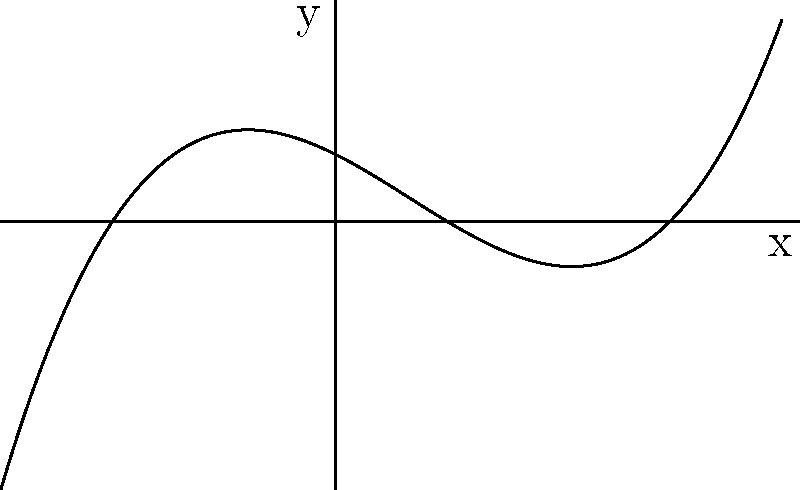As a copyright infringement protection expert, you're analyzing a graph that represents the distribution of plagiarized content over time. The graph resembles a polynomial function. Based on the shape of this graph, determine the number and types of roots (x-intercepts) present. How might these roots relate to significant events or changes in content protection strategies? To determine the number and types of roots from this polynomial graph, let's analyze it step-by-step:

1. X-intercepts: The graph crosses the x-axis at three distinct points. These are the roots of the polynomial.

2. Nature of roots:
   a) The leftmost root is where the graph crosses from below the x-axis to above it.
   b) The middle root is where the graph crosses from above the x-axis to below it.
   c) The rightmost root is where the graph crosses from below the x-axis to above it again.

3. Number of roots: There are 3 distinct roots.

4. Types of roots: All roots appear to be real and distinct (no repeated roots).

5. Degree of polynomial: The graph has two turning points (one maximum and one minimum), suggesting a cubic (3rd degree) polynomial.

In the context of copyright infringement:
- The leftmost root might represent the implementation of a new content protection strategy.
- The middle root could indicate a period where infringement briefly increased due to a new method of plagiarism.
- The rightmost root might represent the successful countering of the new plagiarism method.

The shape between roots could represent fluctuations in plagiarism rates as strategies evolve.
Answer: 3 distinct real roots 